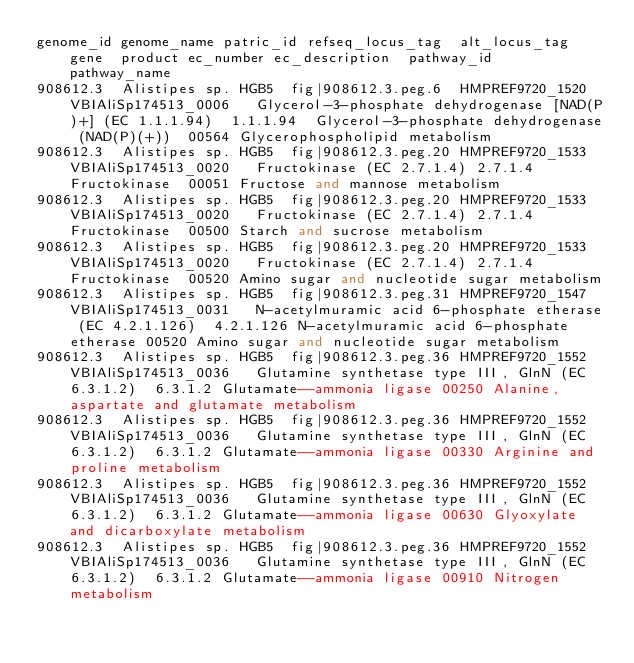Convert code to text. <code><loc_0><loc_0><loc_500><loc_500><_SQL_>genome_id	genome_name	patric_id	refseq_locus_tag	alt_locus_tag	gene	product	ec_number	ec_description	pathway_id	pathway_name
908612.3	Alistipes sp. HGB5	fig|908612.3.peg.6	HMPREF9720_1520	VBIAliSp174513_0006		Glycerol-3-phosphate dehydrogenase [NAD(P)+] (EC 1.1.1.94)	1.1.1.94	Glycerol-3-phosphate dehydrogenase (NAD(P)(+))	00564	Glycerophospholipid metabolism
908612.3	Alistipes sp. HGB5	fig|908612.3.peg.20	HMPREF9720_1533	VBIAliSp174513_0020		Fructokinase (EC 2.7.1.4)	2.7.1.4	Fructokinase	00051	Fructose and mannose metabolism
908612.3	Alistipes sp. HGB5	fig|908612.3.peg.20	HMPREF9720_1533	VBIAliSp174513_0020		Fructokinase (EC 2.7.1.4)	2.7.1.4	Fructokinase	00500	Starch and sucrose metabolism
908612.3	Alistipes sp. HGB5	fig|908612.3.peg.20	HMPREF9720_1533	VBIAliSp174513_0020		Fructokinase (EC 2.7.1.4)	2.7.1.4	Fructokinase	00520	Amino sugar and nucleotide sugar metabolism
908612.3	Alistipes sp. HGB5	fig|908612.3.peg.31	HMPREF9720_1547	VBIAliSp174513_0031		N-acetylmuramic acid 6-phosphate etherase (EC 4.2.1.126)	4.2.1.126	N-acetylmuramic acid 6-phosphate etherase	00520	Amino sugar and nucleotide sugar metabolism
908612.3	Alistipes sp. HGB5	fig|908612.3.peg.36	HMPREF9720_1552	VBIAliSp174513_0036		Glutamine synthetase type III, GlnN (EC 6.3.1.2)	6.3.1.2	Glutamate--ammonia ligase	00250	Alanine, aspartate and glutamate metabolism
908612.3	Alistipes sp. HGB5	fig|908612.3.peg.36	HMPREF9720_1552	VBIAliSp174513_0036		Glutamine synthetase type III, GlnN (EC 6.3.1.2)	6.3.1.2	Glutamate--ammonia ligase	00330	Arginine and proline metabolism
908612.3	Alistipes sp. HGB5	fig|908612.3.peg.36	HMPREF9720_1552	VBIAliSp174513_0036		Glutamine synthetase type III, GlnN (EC 6.3.1.2)	6.3.1.2	Glutamate--ammonia ligase	00630	Glyoxylate and dicarboxylate metabolism
908612.3	Alistipes sp. HGB5	fig|908612.3.peg.36	HMPREF9720_1552	VBIAliSp174513_0036		Glutamine synthetase type III, GlnN (EC 6.3.1.2)	6.3.1.2	Glutamate--ammonia ligase	00910	Nitrogen metabolism</code> 